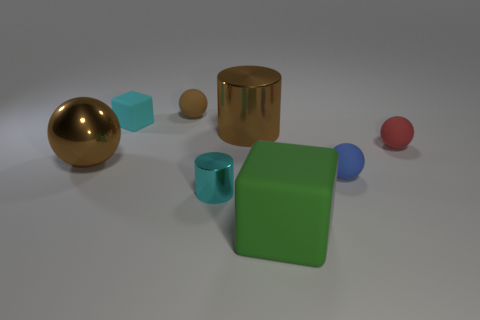Subtract all cubes. How many objects are left? 6 Subtract all big brown metallic balls. How many balls are left? 3 Subtract 0 red cubes. How many objects are left? 8 Subtract 2 cylinders. How many cylinders are left? 0 Subtract all gray cylinders. Subtract all blue spheres. How many cylinders are left? 2 Subtract all purple blocks. How many brown spheres are left? 2 Subtract all blue shiny cylinders. Subtract all red spheres. How many objects are left? 7 Add 1 green blocks. How many green blocks are left? 2 Add 5 big balls. How many big balls exist? 6 Add 2 tiny cyan things. How many objects exist? 10 